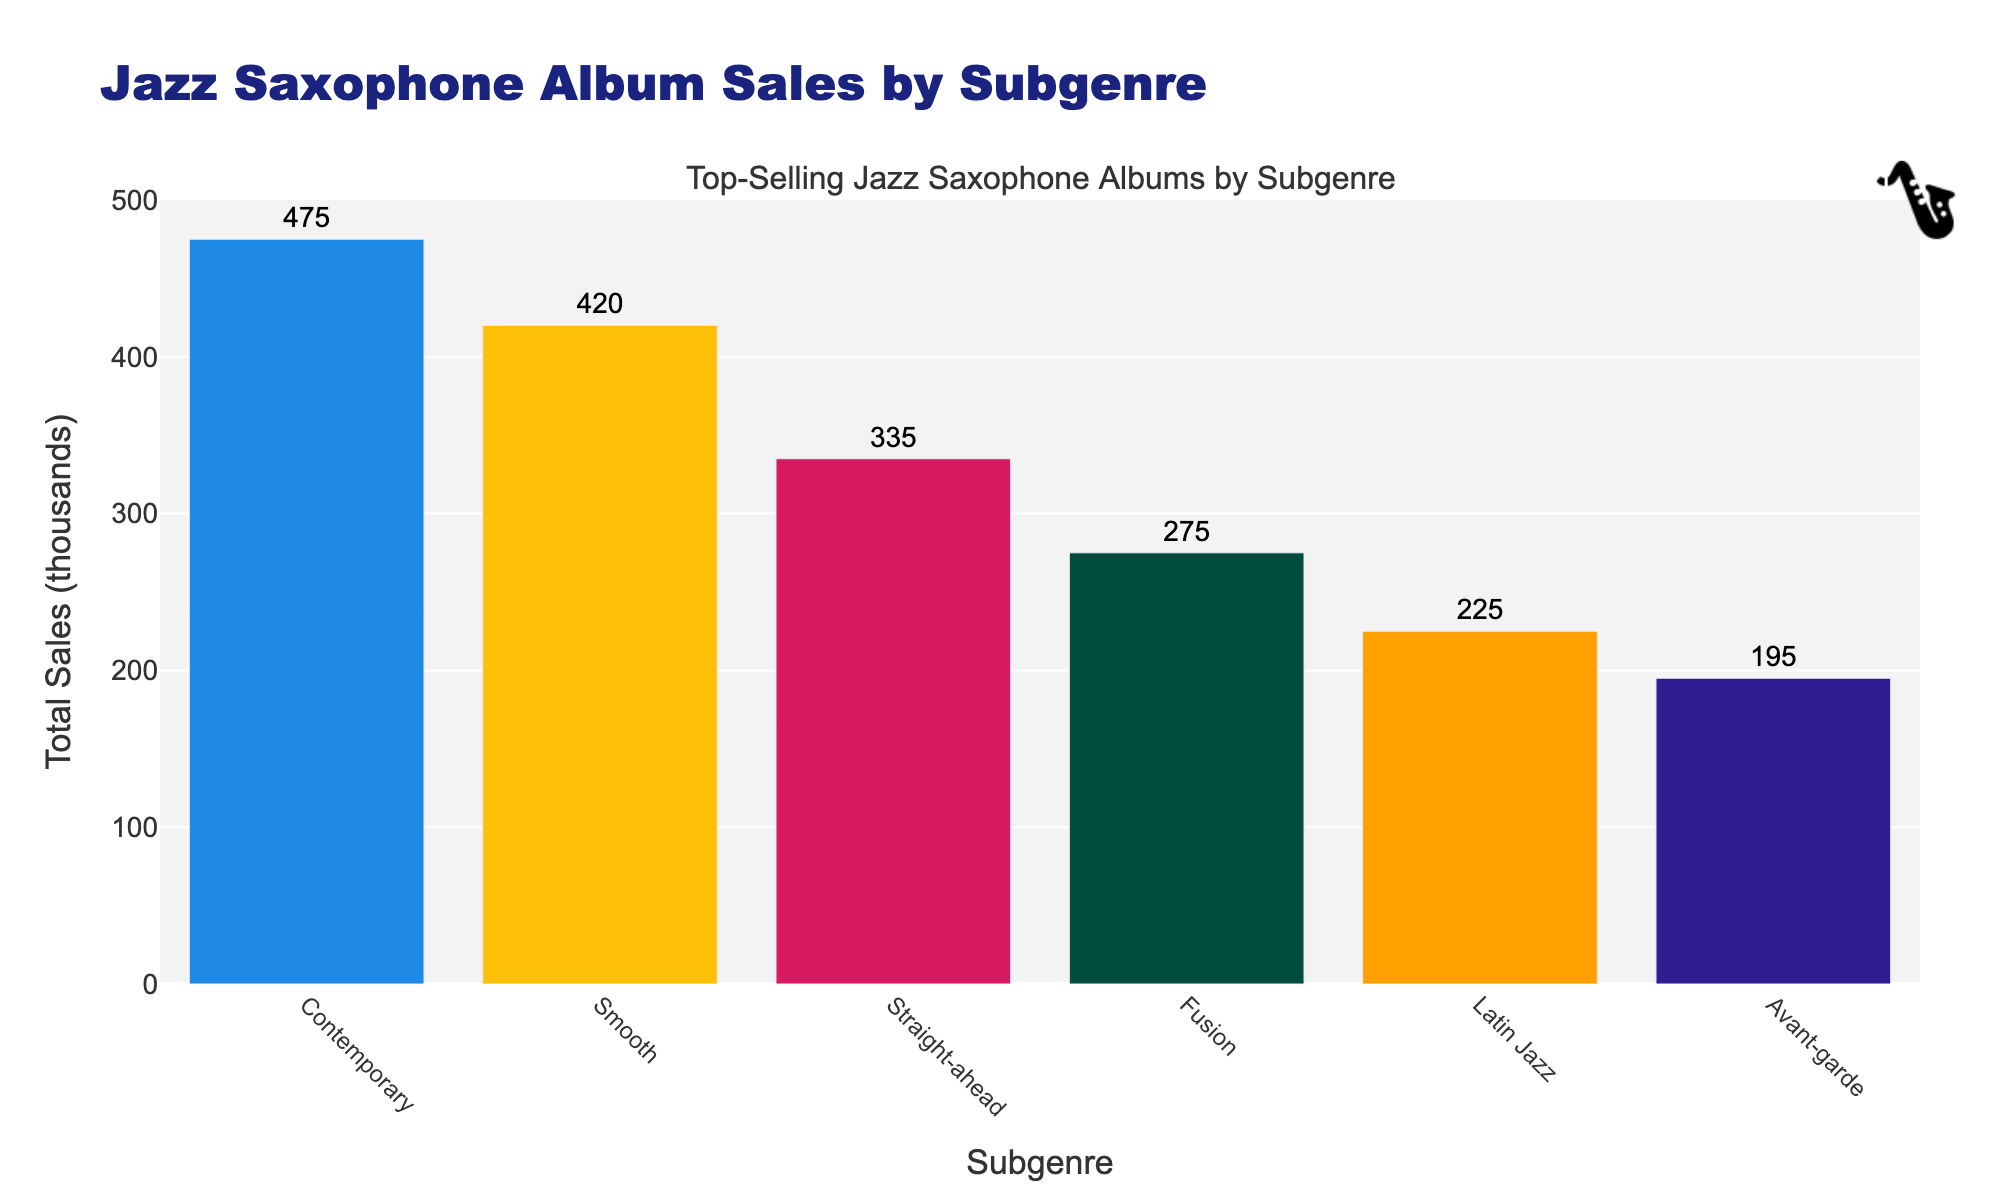Which subgenre has the highest total sales? The subgenre with the highest total sales is at the top of the bar chart with the tallest bar. This indicates it has sold more than the other subgenres.
Answer: Contemporary What are the total sales for the Straight-ahead subgenre? The total sales for the Straight-ahead subgenre are shown as the height of the Straight-ahead bar.
Answer: 335 thousand How much higher are the total sales of Smooth Jazz compared to Avant-garde Jazz? To find this, subtract the total sales of Avant-garde Jazz from the total sales of Smooth Jazz.
Answer: 140 thousand Which subgenre is visually represented by the third tallest bar? The third tallest bar in the chart represents the subgenre that ranks third in total sales.
Answer: Smooth How many subgenres have total sales equal to or greater than 100 thousand? Count the number of bars that have heights representing sales equal to or greater than 100 thousand.
Answer: 4 What is the average sales for the Fusion and Latin Jazz subgenres? Add the total sales for Fusion and Latin Jazz, then divide by 2 to find the average.
Answer: 85 thousand Compare the total sales of Latin Jazz and Straight-ahead Jazz. Which one is greater? Examine the heights of the bars for Latin Jazz and Straight-ahead Jazz. The taller bar represents the subgenre with greater sales.
Answer: Straight-ahead Jazz If the total sales for Avant-garde were to increase by 10 thousand, how would its ranking change relative to other subgenres? Added sales would change the height of the Avant-garde bar and may shift its position relative to others. Calculate the new total and re-rank.
Answer: No change (still the lowest) By how much do the total sales of Contemporary Jazz exceed those of Fusion Jazz? Subtract the total sales of Fusion Jazz from the total sales of Contemporary Jazz.
Answer: 300 thousand 